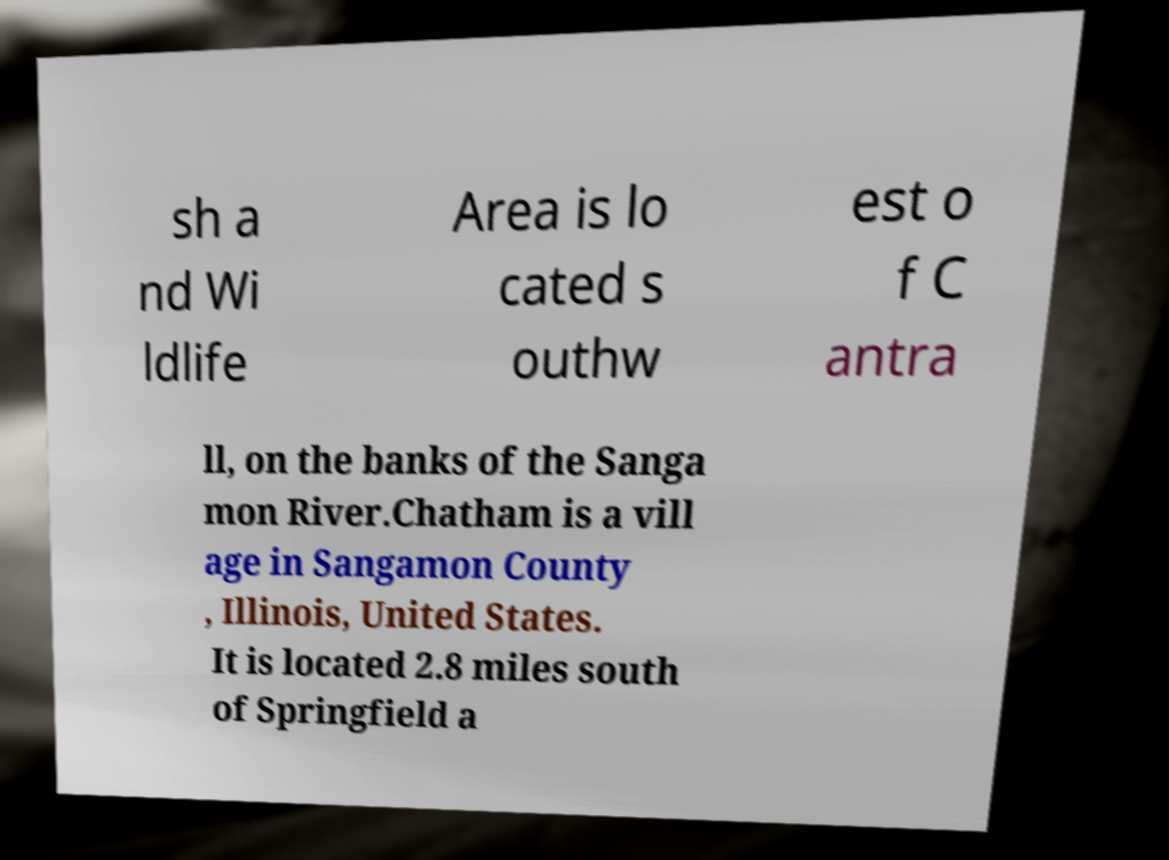There's text embedded in this image that I need extracted. Can you transcribe it verbatim? sh a nd Wi ldlife Area is lo cated s outhw est o f C antra ll, on the banks of the Sanga mon River.Chatham is a vill age in Sangamon County , Illinois, United States. It is located 2.8 miles south of Springfield a 